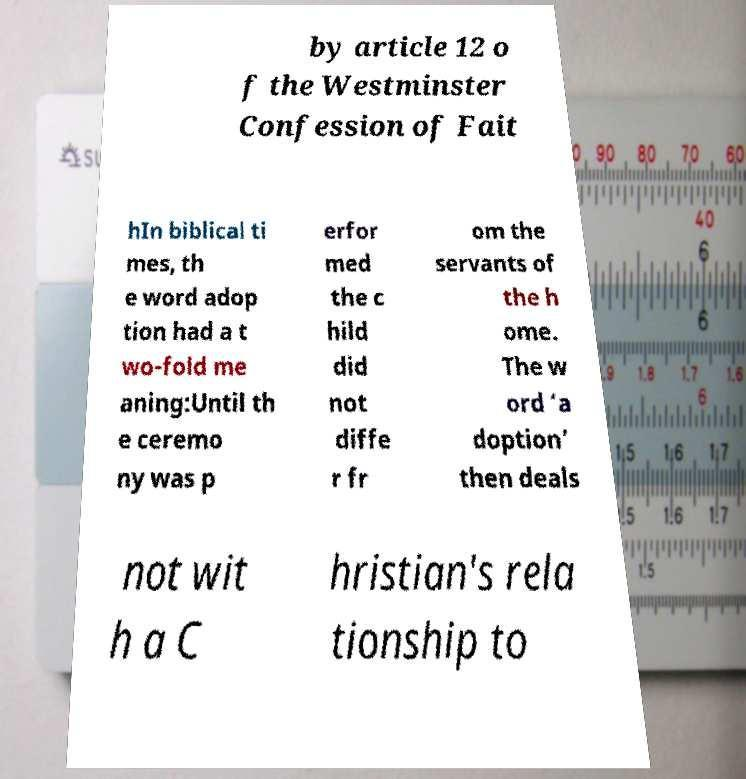Please read and relay the text visible in this image. What does it say? by article 12 o f the Westminster Confession of Fait hIn biblical ti mes, th e word adop tion had a t wo-fold me aning:Until th e ceremo ny was p erfor med the c hild did not diffe r fr om the servants of the h ome. The w ord ‘a doption’ then deals not wit h a C hristian's rela tionship to 